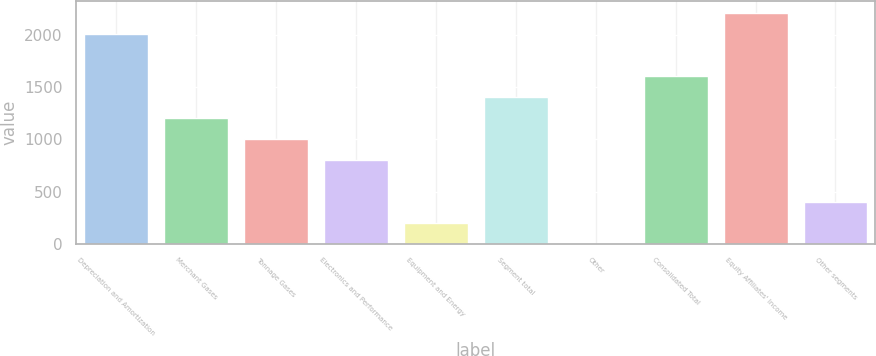Convert chart. <chart><loc_0><loc_0><loc_500><loc_500><bar_chart><fcel>Depreciation and Amortization<fcel>Merchant Gases<fcel>Tonnage Gases<fcel>Electronics and Performance<fcel>Equipment and Energy<fcel>Segment total<fcel>Other<fcel>Consolidated Total<fcel>Equity Affiliates' Income<fcel>Other segments<nl><fcel>2013<fcel>1208.2<fcel>1007<fcel>805.8<fcel>202.2<fcel>1409.4<fcel>1<fcel>1610.6<fcel>2214.2<fcel>403.4<nl></chart> 